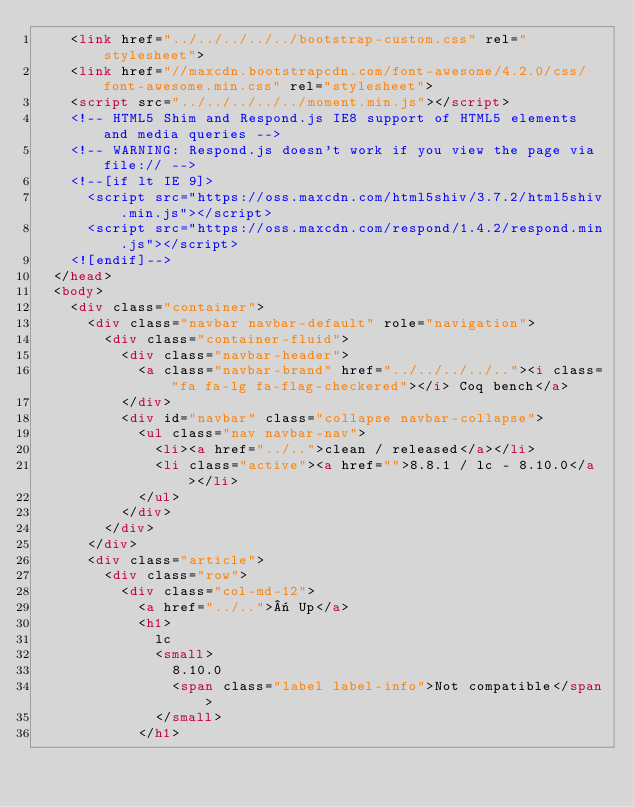<code> <loc_0><loc_0><loc_500><loc_500><_HTML_>    <link href="../../../../../bootstrap-custom.css" rel="stylesheet">
    <link href="//maxcdn.bootstrapcdn.com/font-awesome/4.2.0/css/font-awesome.min.css" rel="stylesheet">
    <script src="../../../../../moment.min.js"></script>
    <!-- HTML5 Shim and Respond.js IE8 support of HTML5 elements and media queries -->
    <!-- WARNING: Respond.js doesn't work if you view the page via file:// -->
    <!--[if lt IE 9]>
      <script src="https://oss.maxcdn.com/html5shiv/3.7.2/html5shiv.min.js"></script>
      <script src="https://oss.maxcdn.com/respond/1.4.2/respond.min.js"></script>
    <![endif]-->
  </head>
  <body>
    <div class="container">
      <div class="navbar navbar-default" role="navigation">
        <div class="container-fluid">
          <div class="navbar-header">
            <a class="navbar-brand" href="../../../../.."><i class="fa fa-lg fa-flag-checkered"></i> Coq bench</a>
          </div>
          <div id="navbar" class="collapse navbar-collapse">
            <ul class="nav navbar-nav">
              <li><a href="../..">clean / released</a></li>
              <li class="active"><a href="">8.8.1 / lc - 8.10.0</a></li>
            </ul>
          </div>
        </div>
      </div>
      <div class="article">
        <div class="row">
          <div class="col-md-12">
            <a href="../..">« Up</a>
            <h1>
              lc
              <small>
                8.10.0
                <span class="label label-info">Not compatible</span>
              </small>
            </h1></code> 